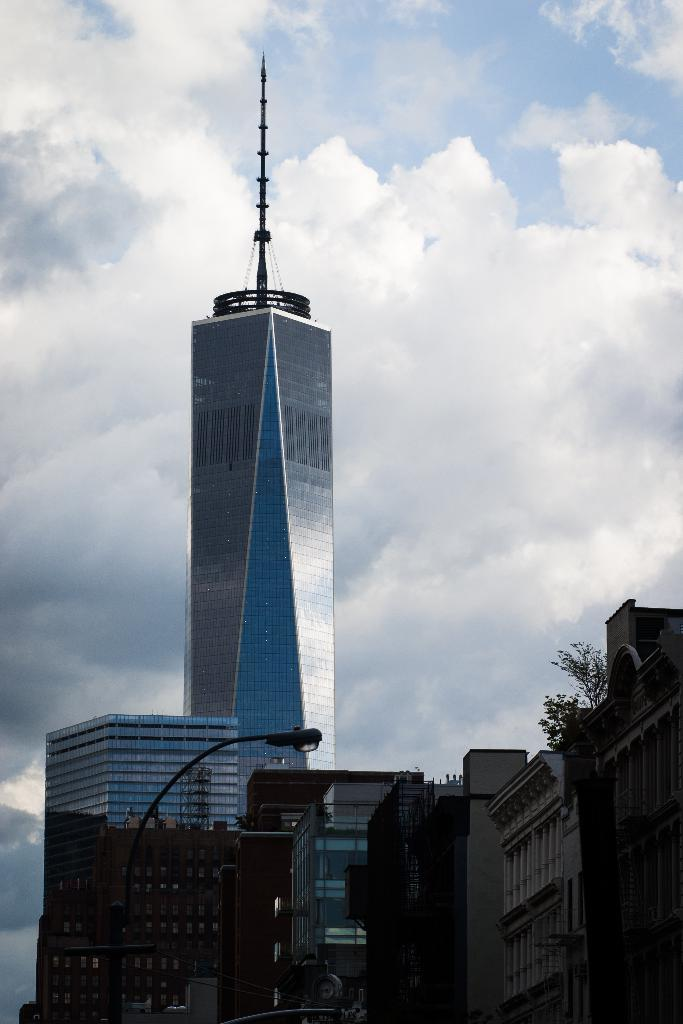What is the main structure in the image? There is a tower in the image. What else can be seen in the image besides the tower? There are buildings, a street light, trees, and some objects in the image. Can you describe the lighting in the image? A street light is visible in the image. What is visible in the background of the image? The sky is visible in the background of the image. Can you see a tiger playing basketball in the image? No, there is no tiger or basketball present in the image. 